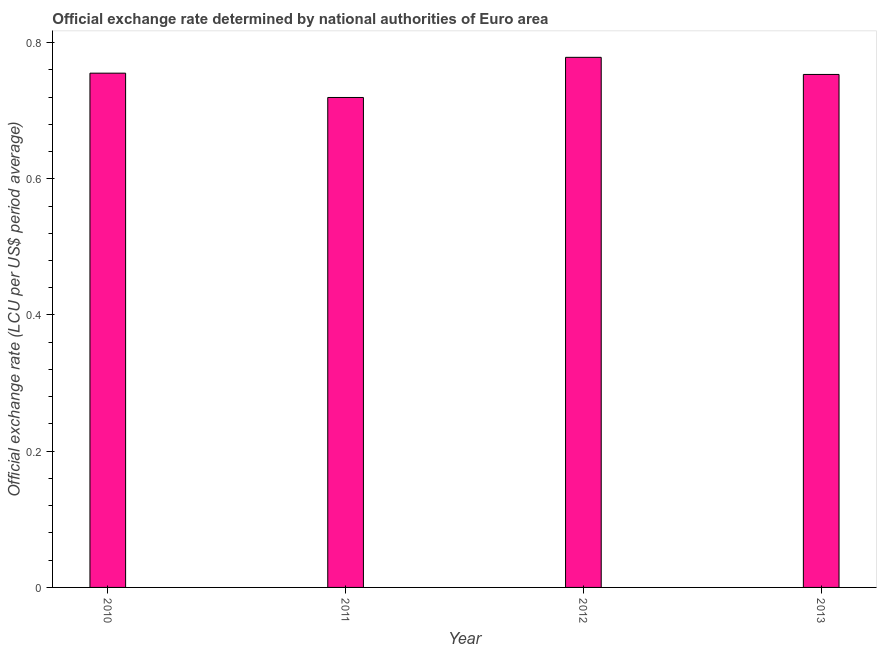Does the graph contain any zero values?
Give a very brief answer. No. Does the graph contain grids?
Make the answer very short. No. What is the title of the graph?
Provide a short and direct response. Official exchange rate determined by national authorities of Euro area. What is the label or title of the Y-axis?
Make the answer very short. Official exchange rate (LCU per US$ period average). What is the official exchange rate in 2013?
Give a very brief answer. 0.75. Across all years, what is the maximum official exchange rate?
Provide a short and direct response. 0.78. Across all years, what is the minimum official exchange rate?
Offer a terse response. 0.72. In which year was the official exchange rate maximum?
Your response must be concise. 2012. In which year was the official exchange rate minimum?
Make the answer very short. 2011. What is the sum of the official exchange rate?
Your response must be concise. 3.01. What is the difference between the official exchange rate in 2010 and 2012?
Offer a very short reply. -0.02. What is the average official exchange rate per year?
Your response must be concise. 0.75. What is the median official exchange rate?
Make the answer very short. 0.75. In how many years, is the official exchange rate greater than 0.2 ?
Keep it short and to the point. 4. What is the ratio of the official exchange rate in 2010 to that in 2013?
Keep it short and to the point. 1. What is the difference between the highest and the second highest official exchange rate?
Make the answer very short. 0.02. Is the sum of the official exchange rate in 2010 and 2012 greater than the maximum official exchange rate across all years?
Your answer should be compact. Yes. What is the difference between the highest and the lowest official exchange rate?
Your answer should be very brief. 0.06. How many bars are there?
Make the answer very short. 4. What is the Official exchange rate (LCU per US$ period average) of 2010?
Your response must be concise. 0.76. What is the Official exchange rate (LCU per US$ period average) in 2011?
Provide a succinct answer. 0.72. What is the Official exchange rate (LCU per US$ period average) of 2012?
Your response must be concise. 0.78. What is the Official exchange rate (LCU per US$ period average) of 2013?
Provide a succinct answer. 0.75. What is the difference between the Official exchange rate (LCU per US$ period average) in 2010 and 2011?
Your response must be concise. 0.04. What is the difference between the Official exchange rate (LCU per US$ period average) in 2010 and 2012?
Provide a short and direct response. -0.02. What is the difference between the Official exchange rate (LCU per US$ period average) in 2010 and 2013?
Your answer should be very brief. 0. What is the difference between the Official exchange rate (LCU per US$ period average) in 2011 and 2012?
Offer a terse response. -0.06. What is the difference between the Official exchange rate (LCU per US$ period average) in 2011 and 2013?
Give a very brief answer. -0.03. What is the difference between the Official exchange rate (LCU per US$ period average) in 2012 and 2013?
Ensure brevity in your answer.  0.03. What is the ratio of the Official exchange rate (LCU per US$ period average) in 2010 to that in 2012?
Your response must be concise. 0.97. What is the ratio of the Official exchange rate (LCU per US$ period average) in 2011 to that in 2012?
Offer a very short reply. 0.92. What is the ratio of the Official exchange rate (LCU per US$ period average) in 2011 to that in 2013?
Keep it short and to the point. 0.95. What is the ratio of the Official exchange rate (LCU per US$ period average) in 2012 to that in 2013?
Make the answer very short. 1.03. 